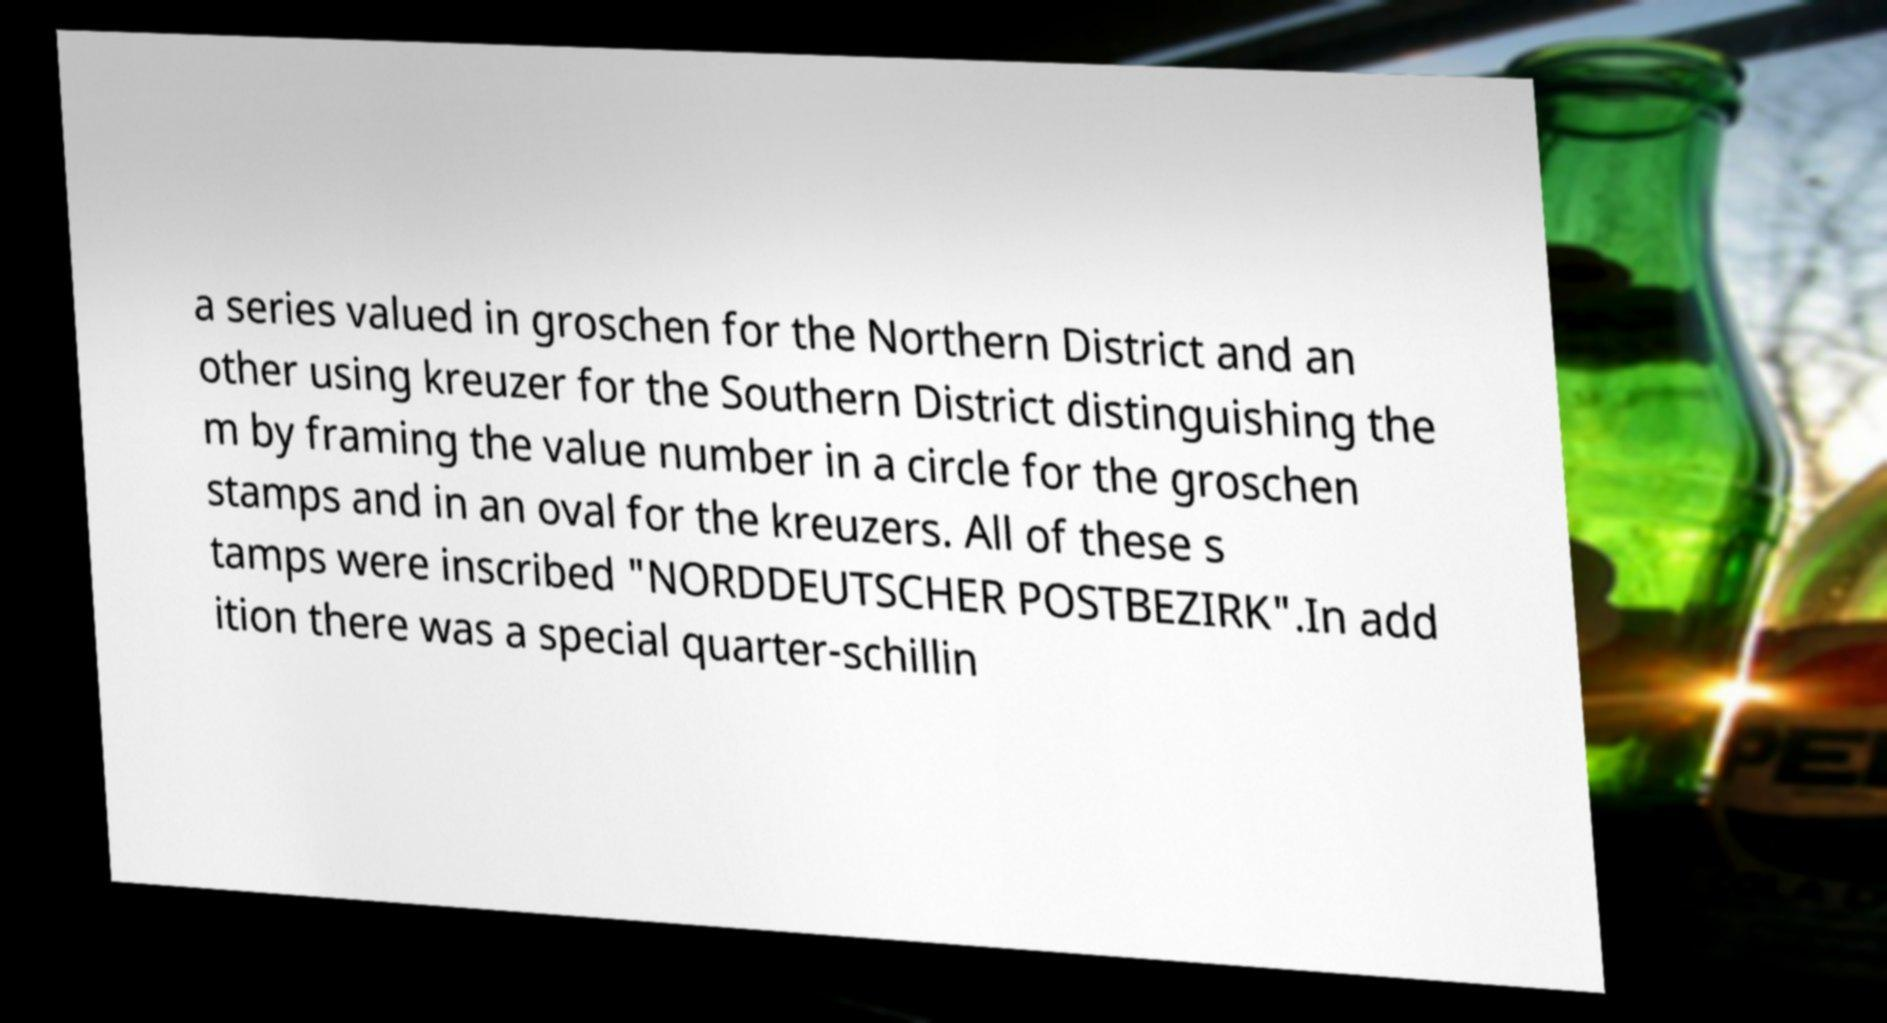There's text embedded in this image that I need extracted. Can you transcribe it verbatim? a series valued in groschen for the Northern District and an other using kreuzer for the Southern District distinguishing the m by framing the value number in a circle for the groschen stamps and in an oval for the kreuzers. All of these s tamps were inscribed "NORDDEUTSCHER POSTBEZIRK".In add ition there was a special quarter-schillin 